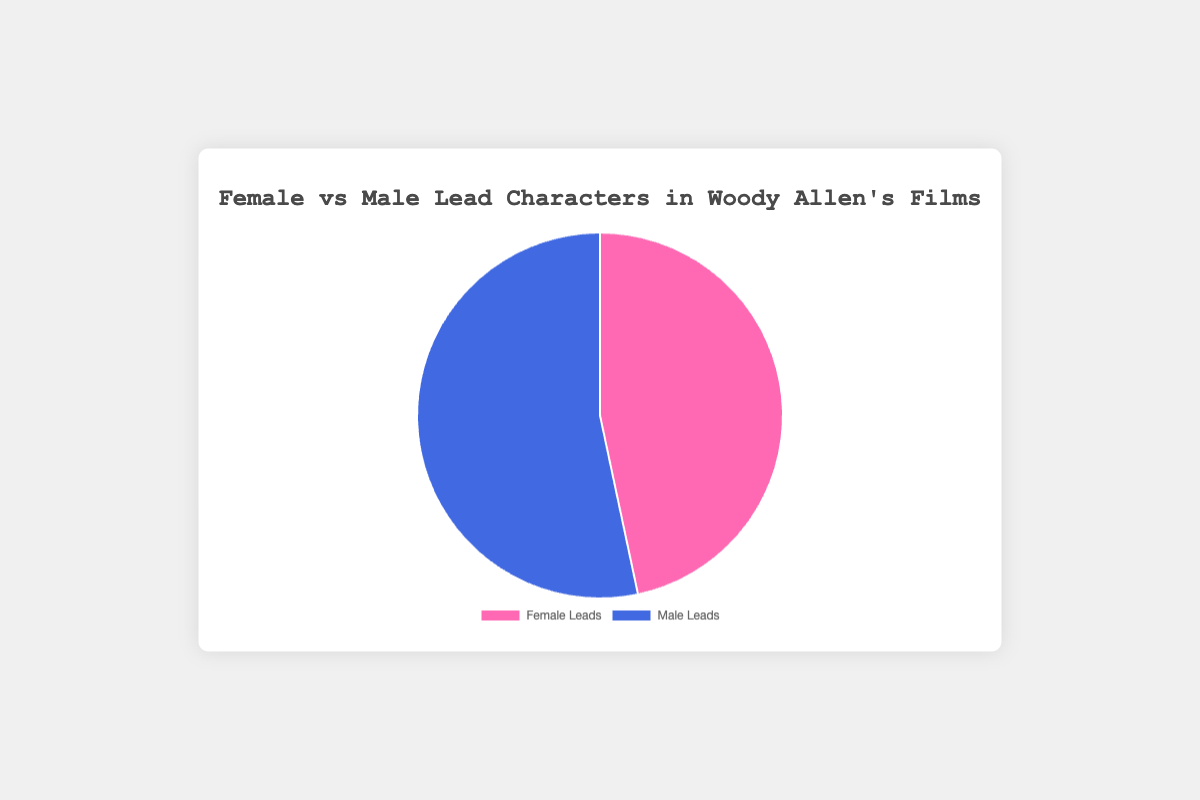What percentage of Woody Allen's films feature a female lead character? To determine the percentage, refer to the pie chart and identify the portion labeled "Female Leads." From the figure, it represents one of two data points. The value is approximately 53.3%.
Answer: 53.3% How many films have female leads versus male leads? Count the number of segments in each label category from the pie chart. There are 8 films with female leads and 7 films with male leads.
Answer: Female: 8, Male: 7 Which category (female or male leads) has more films, and by how many? Compare the counts of the segments for each category. Female Lead has 8 films, and Male Lead has 7 films. Thus, Female Lead has one more film.
Answer: Female leads by 1 film What is the difference in the number of films with female leads compared to male leads? To find the difference, subtract the number of male lead films from female lead films. There are 8 female lead films and 7 male lead films, so 8 - 7 = 1.
Answer: 1 How many films feature male leads as a percentage? Calculate the percentage by dividing the number of male lead films by total films and multiply by 100: (7/15) * 100 = 46.7%.
Answer: 46.7% What are the exact counts of female and male lead films? Refer to the data in the pie chart. The counts are explicitly labeled as 8 films for Female Leads and 7 films for Male Leads.
Answer: Female: 8, Male: 7 What is the combined number of films with either male or female leads? Sum the number of films with female and male leads. This is the total number of films represented in the chart: 8(Female) + 7(Male) = 15 films in total.
Answer: 15 films Is the number of female lead films equal to or greater than the number of male lead films? Compare the segment size for Female Leads and Male Leads from the pie chart. There are 8 female lead films and 7 male lead films, so female leads are greater.
Answer: Greater than What is the ratio of female lead films to male lead films? To find the ratio, divide the number of female lead films by the number of male lead films. The calculation is 8/7, which simplifies to approximately 1.14:1.
Answer: 1.14:1 What color represents male lead films in the pie chart? The pie chart uses specific colors to differentiate categories. Male lead films are represented by the blue segment.
Answer: Blue 